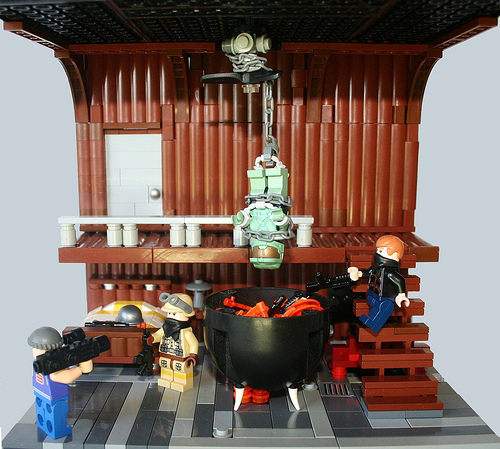<image>
Can you confirm if the toy is to the left of the toy? No. The toy is not to the left of the toy. From this viewpoint, they have a different horizontal relationship. 